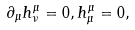Convert formula to latex. <formula><loc_0><loc_0><loc_500><loc_500>\partial _ { \mu } h ^ { \mu } _ { \nu } = 0 , h _ { \mu } ^ { \mu } = 0 ,</formula> 